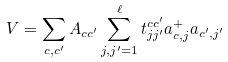<formula> <loc_0><loc_0><loc_500><loc_500>V = \sum _ { c , c ^ { \prime } } A _ { c c ^ { \prime } } \sum _ { j , j ^ { \prime } = 1 } ^ { \ell } t ^ { c c ^ { \prime } } _ { j j ^ { \prime } } a ^ { + } _ { c , j } a _ { c ^ { \prime } , j ^ { \prime } }</formula> 